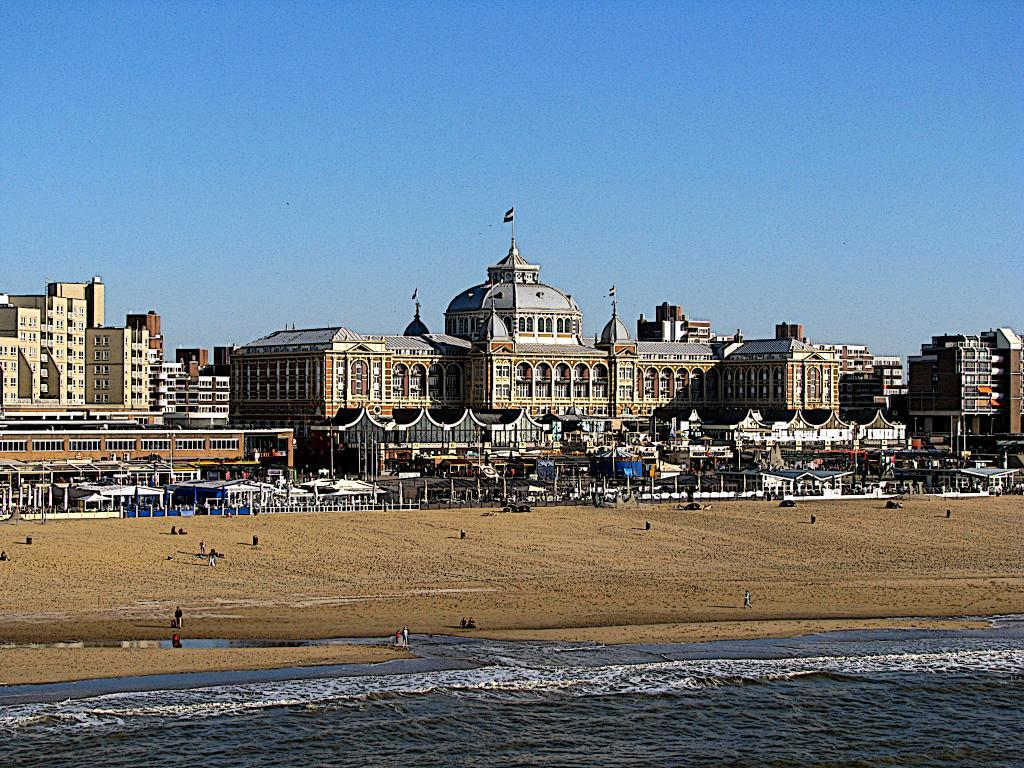What type of location is depicted in the image? There is a beach in the image. What can be seen at the bottom of the image? There is water visible at the bottom of the image. What structures are present in the middle of the image? There are buildings in the middle of the image. What type of quiver can be seen in the image? There is no quiver present in the image. What effect does the water have on the buildings in the image? The image does not show any interaction between the water and the buildings, so it is not possible to determine any effect. 